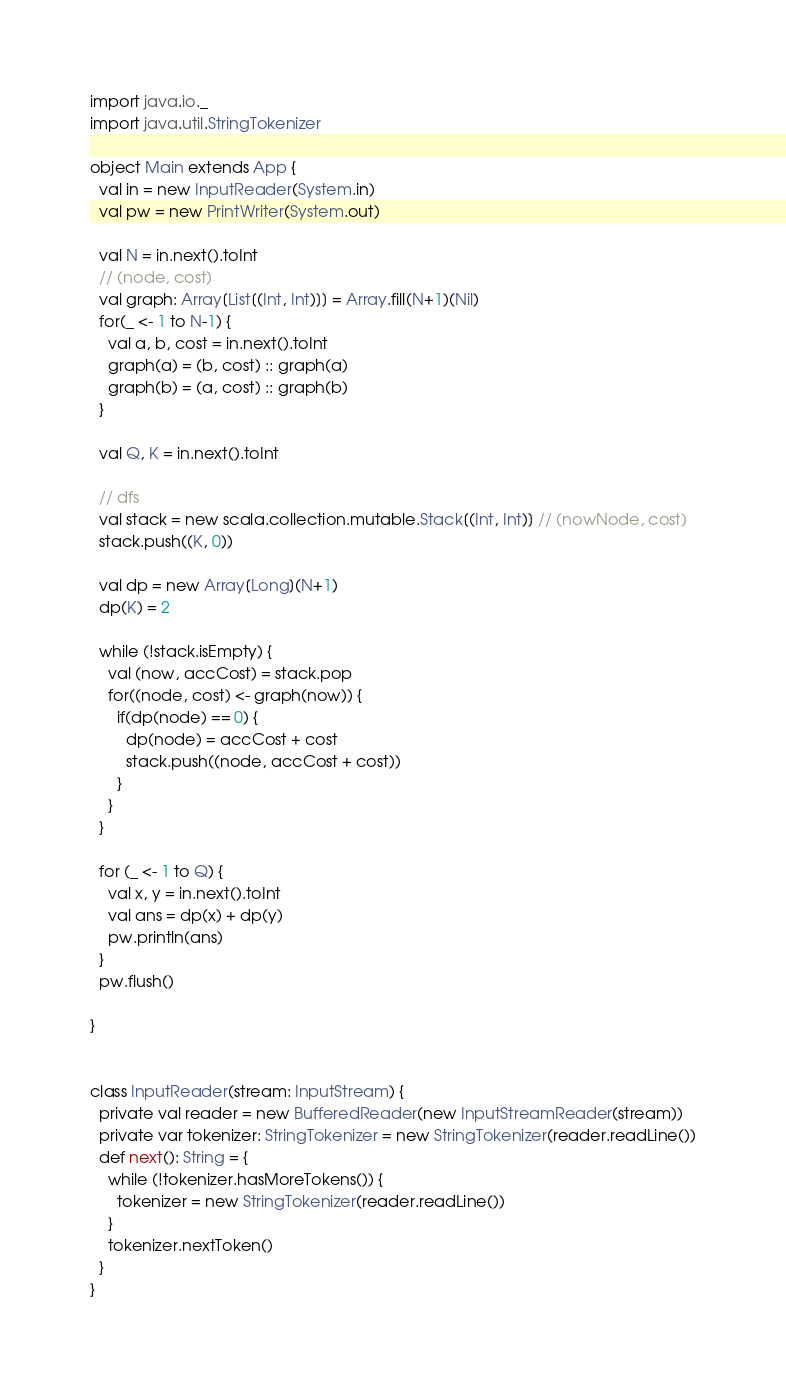<code> <loc_0><loc_0><loc_500><loc_500><_Scala_>import java.io._
import java.util.StringTokenizer

object Main extends App {
  val in = new InputReader(System.in)
  val pw = new PrintWriter(System.out)

  val N = in.next().toInt
  // (node, cost)
  val graph: Array[List[(Int, Int)]] = Array.fill(N+1)(Nil)
  for(_ <- 1 to N-1) {
    val a, b, cost = in.next().toInt
    graph(a) = (b, cost) :: graph(a)
    graph(b) = (a, cost) :: graph(b)
  }

  val Q, K = in.next().toInt

  // dfs
  val stack = new scala.collection.mutable.Stack[(Int, Int)] // (nowNode, cost)
  stack.push((K, 0))

  val dp = new Array[Long](N+1)
  dp(K) = 2

  while (!stack.isEmpty) {
    val (now, accCost) = stack.pop
    for((node, cost) <- graph(now)) {
      if(dp(node) == 0) {
        dp(node) = accCost + cost
        stack.push((node, accCost + cost))
      }
    }
  }

  for (_ <- 1 to Q) {
    val x, y = in.next().toInt
    val ans = dp(x) + dp(y)
    pw.println(ans)
  }
  pw.flush()

}


class InputReader(stream: InputStream) {
  private val reader = new BufferedReader(new InputStreamReader(stream))
  private var tokenizer: StringTokenizer = new StringTokenizer(reader.readLine())
  def next(): String = {
    while (!tokenizer.hasMoreTokens()) {
      tokenizer = new StringTokenizer(reader.readLine())
    }
    tokenizer.nextToken()
  }
}
</code> 